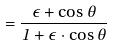<formula> <loc_0><loc_0><loc_500><loc_500>= \frac { \epsilon + \cos \theta } { 1 + \epsilon \cdot \cos \theta }</formula> 